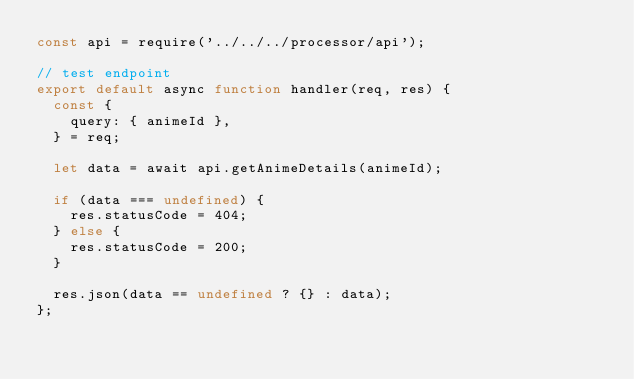Convert code to text. <code><loc_0><loc_0><loc_500><loc_500><_JavaScript_>const api = require('../../../processor/api');

// test endpoint
export default async function handler(req, res) {
  const {
    query: { animeId },
  } = req;

  let data = await api.getAnimeDetails(animeId);

  if (data === undefined) {
    res.statusCode = 404;
  } else {
    res.statusCode = 200;
  }

  res.json(data == undefined ? {} : data);
};
</code> 